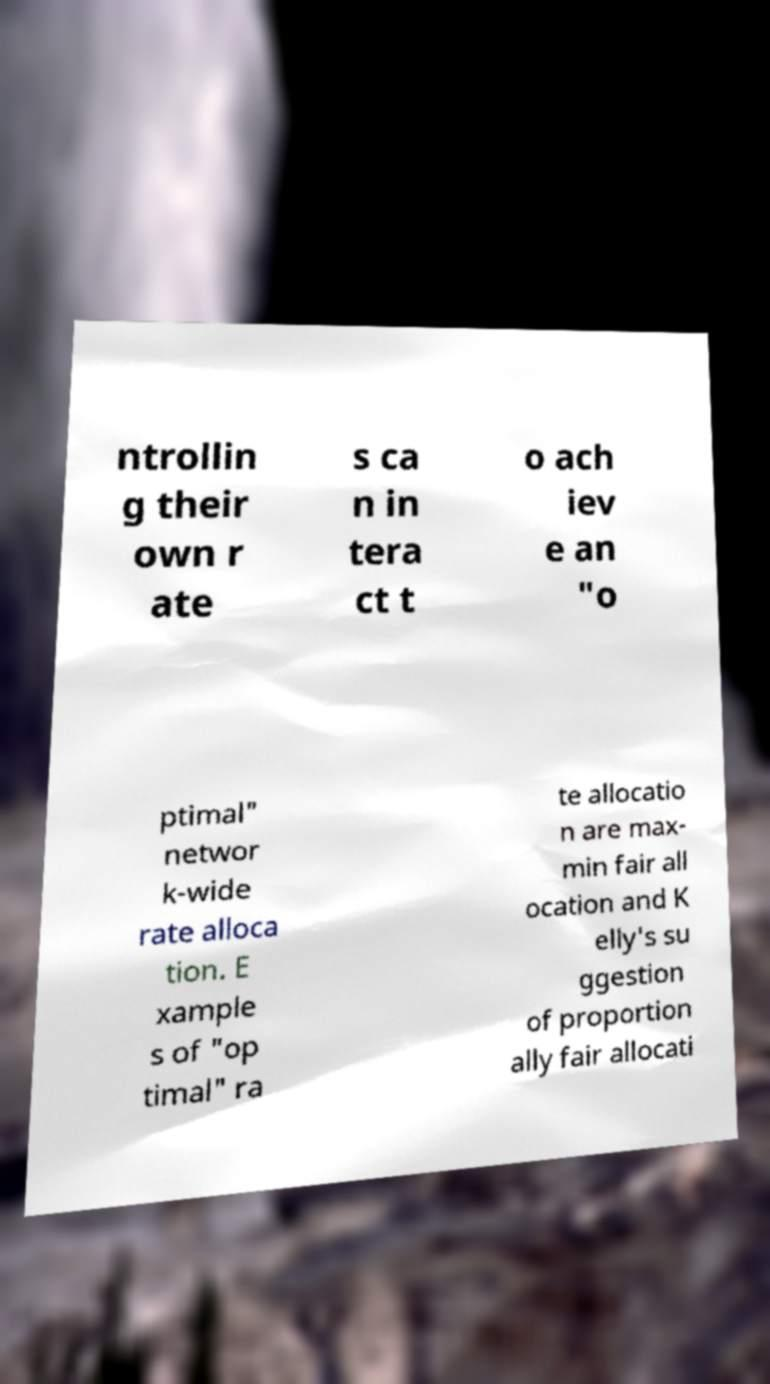Can you accurately transcribe the text from the provided image for me? ntrollin g their own r ate s ca n in tera ct t o ach iev e an "o ptimal" networ k-wide rate alloca tion. E xample s of "op timal" ra te allocatio n are max- min fair all ocation and K elly's su ggestion of proportion ally fair allocati 